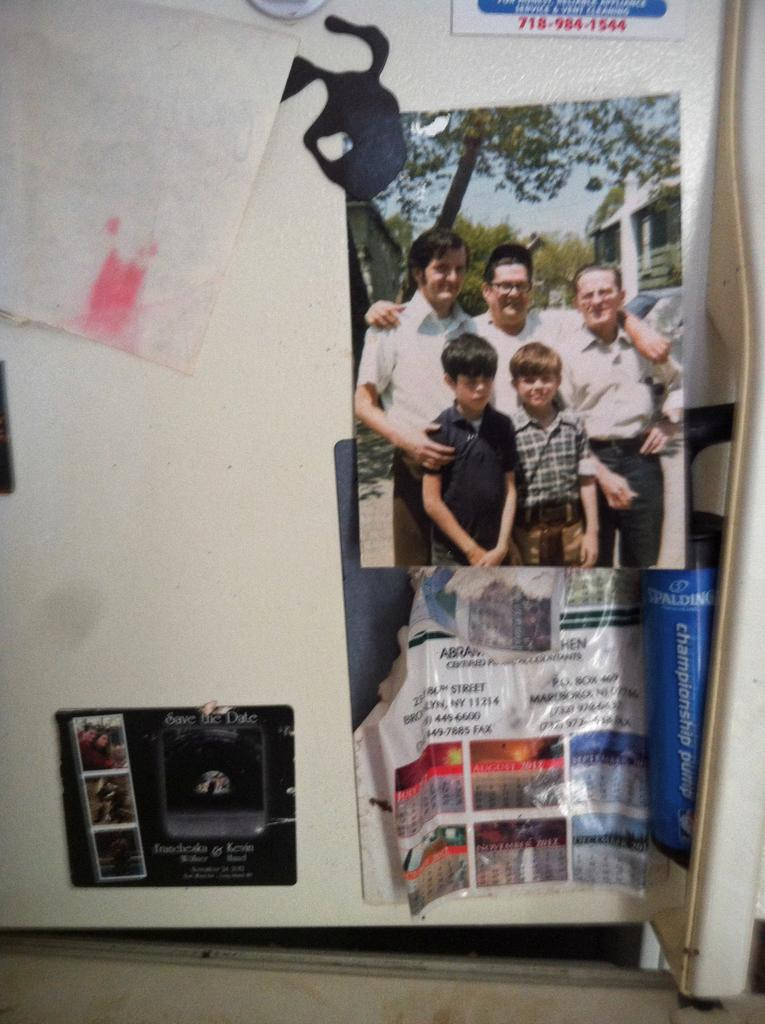What type of items can be seen in the image? There are photos, paper, and objects in the image. Can you describe the board at the bottom of the image? There is a board at the bottom of the image, but its specific characteristics are not mentioned in the facts. Is there any indication of an entrance or exit in the image? There might be a door in the background of the image, but its presence is not confirmed. How does the disgusting bee feel about the comparison in the image? There is no bee or comparison present in the image, so this question cannot be answered. 